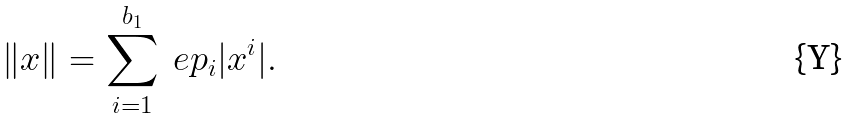Convert formula to latex. <formula><loc_0><loc_0><loc_500><loc_500>\| x \| = \sum _ { i = 1 } ^ { b _ { 1 } } \ e p _ { i } | x ^ { i } | .</formula> 